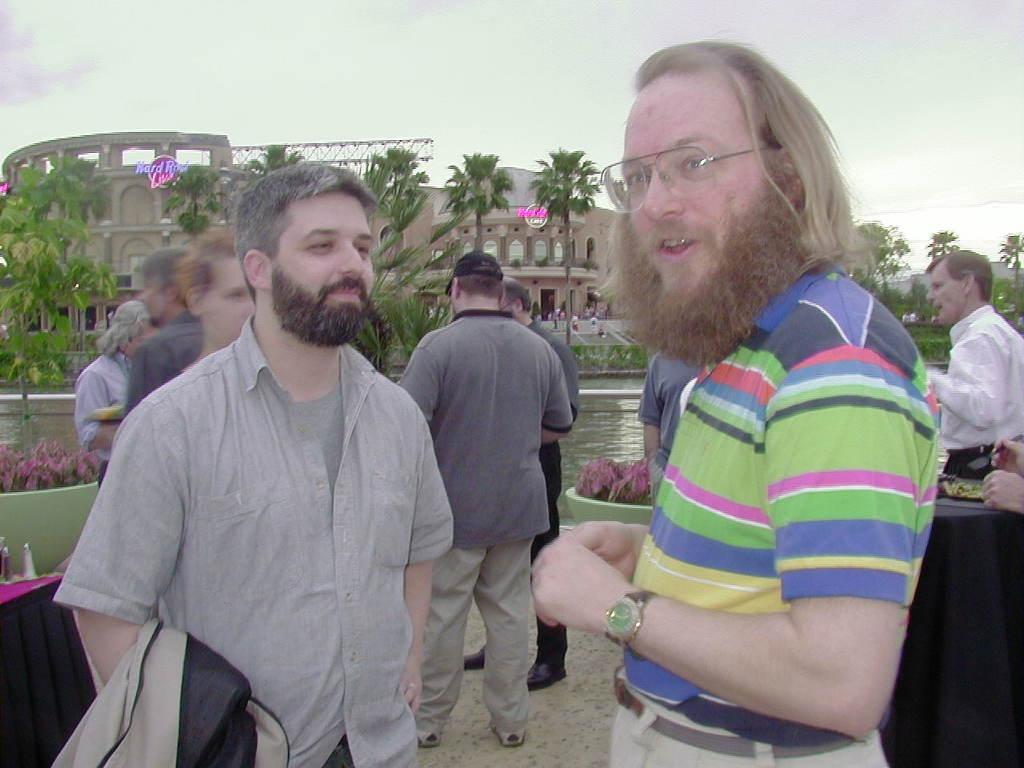How would you summarize this image in a sentence or two? In this image we can see a group of people standing. We can also see the tables with some objects on them, some plants with flowers, a metal fence, a group of plants, the metal frame, a water body, a building and the sky which looks cloudy. 